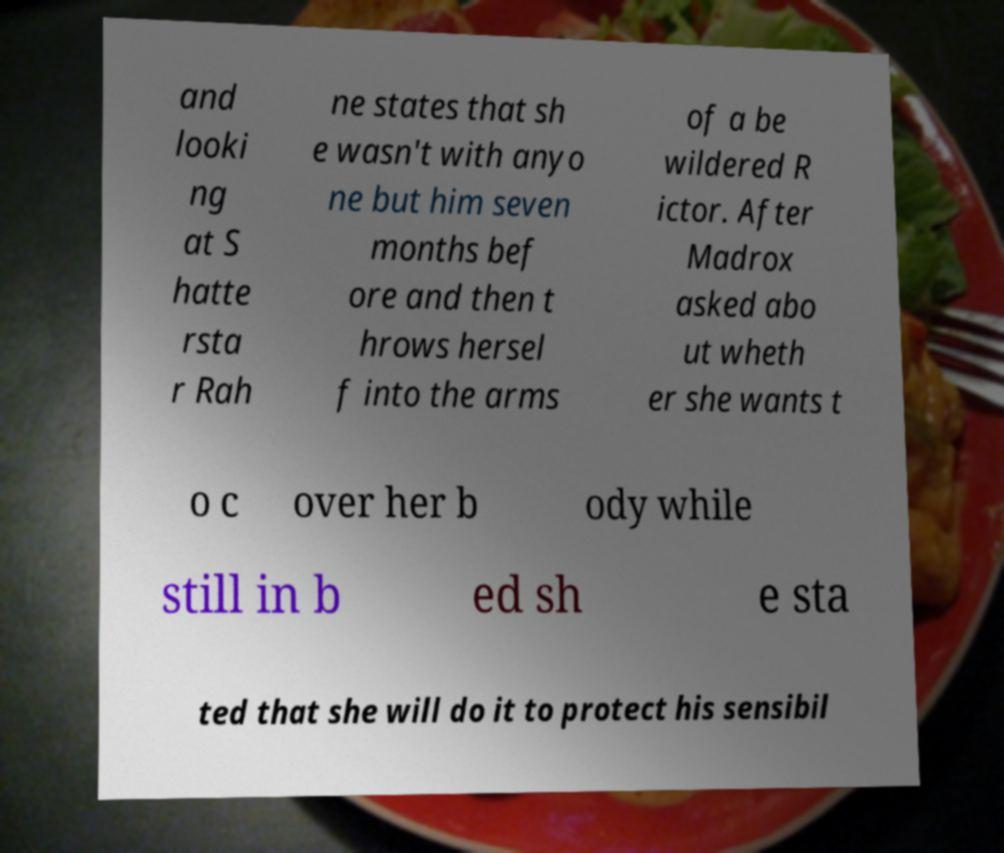For documentation purposes, I need the text within this image transcribed. Could you provide that? and looki ng at S hatte rsta r Rah ne states that sh e wasn't with anyo ne but him seven months bef ore and then t hrows hersel f into the arms of a be wildered R ictor. After Madrox asked abo ut wheth er she wants t o c over her b ody while still in b ed sh e sta ted that she will do it to protect his sensibil 